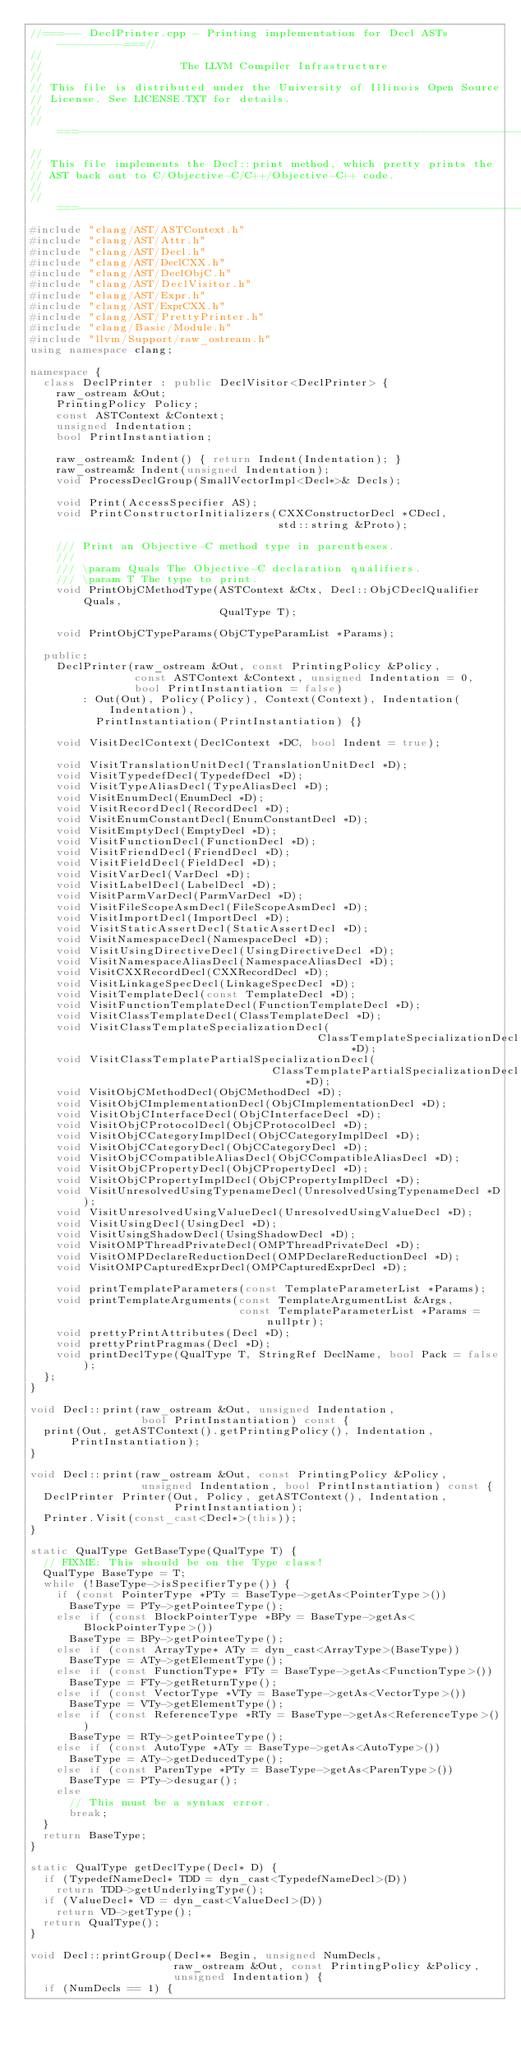Convert code to text. <code><loc_0><loc_0><loc_500><loc_500><_C++_>//===--- DeclPrinter.cpp - Printing implementation for Decl ASTs ----------===//
//
//                     The LLVM Compiler Infrastructure
//
// This file is distributed under the University of Illinois Open Source
// License. See LICENSE.TXT for details.
//
//===----------------------------------------------------------------------===//
//
// This file implements the Decl::print method, which pretty prints the
// AST back out to C/Objective-C/C++/Objective-C++ code.
//
//===----------------------------------------------------------------------===//
#include "clang/AST/ASTContext.h"
#include "clang/AST/Attr.h"
#include "clang/AST/Decl.h"
#include "clang/AST/DeclCXX.h"
#include "clang/AST/DeclObjC.h"
#include "clang/AST/DeclVisitor.h"
#include "clang/AST/Expr.h"
#include "clang/AST/ExprCXX.h"
#include "clang/AST/PrettyPrinter.h"
#include "clang/Basic/Module.h"
#include "llvm/Support/raw_ostream.h"
using namespace clang;

namespace {
  class DeclPrinter : public DeclVisitor<DeclPrinter> {
    raw_ostream &Out;
    PrintingPolicy Policy;
    const ASTContext &Context;
    unsigned Indentation;
    bool PrintInstantiation;

    raw_ostream& Indent() { return Indent(Indentation); }
    raw_ostream& Indent(unsigned Indentation);
    void ProcessDeclGroup(SmallVectorImpl<Decl*>& Decls);

    void Print(AccessSpecifier AS);
    void PrintConstructorInitializers(CXXConstructorDecl *CDecl,
                                      std::string &Proto);

    /// Print an Objective-C method type in parentheses.
    ///
    /// \param Quals The Objective-C declaration qualifiers.
    /// \param T The type to print.
    void PrintObjCMethodType(ASTContext &Ctx, Decl::ObjCDeclQualifier Quals, 
                             QualType T);

    void PrintObjCTypeParams(ObjCTypeParamList *Params);

  public:
    DeclPrinter(raw_ostream &Out, const PrintingPolicy &Policy,
                const ASTContext &Context, unsigned Indentation = 0,
                bool PrintInstantiation = false)
        : Out(Out), Policy(Policy), Context(Context), Indentation(Indentation),
          PrintInstantiation(PrintInstantiation) {}

    void VisitDeclContext(DeclContext *DC, bool Indent = true);

    void VisitTranslationUnitDecl(TranslationUnitDecl *D);
    void VisitTypedefDecl(TypedefDecl *D);
    void VisitTypeAliasDecl(TypeAliasDecl *D);
    void VisitEnumDecl(EnumDecl *D);
    void VisitRecordDecl(RecordDecl *D);
    void VisitEnumConstantDecl(EnumConstantDecl *D);
    void VisitEmptyDecl(EmptyDecl *D);
    void VisitFunctionDecl(FunctionDecl *D);
    void VisitFriendDecl(FriendDecl *D);
    void VisitFieldDecl(FieldDecl *D);
    void VisitVarDecl(VarDecl *D);
    void VisitLabelDecl(LabelDecl *D);
    void VisitParmVarDecl(ParmVarDecl *D);
    void VisitFileScopeAsmDecl(FileScopeAsmDecl *D);
    void VisitImportDecl(ImportDecl *D);
    void VisitStaticAssertDecl(StaticAssertDecl *D);
    void VisitNamespaceDecl(NamespaceDecl *D);
    void VisitUsingDirectiveDecl(UsingDirectiveDecl *D);
    void VisitNamespaceAliasDecl(NamespaceAliasDecl *D);
    void VisitCXXRecordDecl(CXXRecordDecl *D);
    void VisitLinkageSpecDecl(LinkageSpecDecl *D);
    void VisitTemplateDecl(const TemplateDecl *D);
    void VisitFunctionTemplateDecl(FunctionTemplateDecl *D);
    void VisitClassTemplateDecl(ClassTemplateDecl *D);
    void VisitClassTemplateSpecializationDecl(
                                            ClassTemplateSpecializationDecl *D);
    void VisitClassTemplatePartialSpecializationDecl(
                                     ClassTemplatePartialSpecializationDecl *D);
    void VisitObjCMethodDecl(ObjCMethodDecl *D);
    void VisitObjCImplementationDecl(ObjCImplementationDecl *D);
    void VisitObjCInterfaceDecl(ObjCInterfaceDecl *D);
    void VisitObjCProtocolDecl(ObjCProtocolDecl *D);
    void VisitObjCCategoryImplDecl(ObjCCategoryImplDecl *D);
    void VisitObjCCategoryDecl(ObjCCategoryDecl *D);
    void VisitObjCCompatibleAliasDecl(ObjCCompatibleAliasDecl *D);
    void VisitObjCPropertyDecl(ObjCPropertyDecl *D);
    void VisitObjCPropertyImplDecl(ObjCPropertyImplDecl *D);
    void VisitUnresolvedUsingTypenameDecl(UnresolvedUsingTypenameDecl *D);
    void VisitUnresolvedUsingValueDecl(UnresolvedUsingValueDecl *D);
    void VisitUsingDecl(UsingDecl *D);
    void VisitUsingShadowDecl(UsingShadowDecl *D);
    void VisitOMPThreadPrivateDecl(OMPThreadPrivateDecl *D);
    void VisitOMPDeclareReductionDecl(OMPDeclareReductionDecl *D);
    void VisitOMPCapturedExprDecl(OMPCapturedExprDecl *D);

    void printTemplateParameters(const TemplateParameterList *Params);
    void printTemplateArguments(const TemplateArgumentList &Args,
                                const TemplateParameterList *Params = nullptr);
    void prettyPrintAttributes(Decl *D);
    void prettyPrintPragmas(Decl *D);
    void printDeclType(QualType T, StringRef DeclName, bool Pack = false);
  };
}

void Decl::print(raw_ostream &Out, unsigned Indentation,
                 bool PrintInstantiation) const {
  print(Out, getASTContext().getPrintingPolicy(), Indentation, PrintInstantiation);
}

void Decl::print(raw_ostream &Out, const PrintingPolicy &Policy,
                 unsigned Indentation, bool PrintInstantiation) const {
  DeclPrinter Printer(Out, Policy, getASTContext(), Indentation,
                      PrintInstantiation);
  Printer.Visit(const_cast<Decl*>(this));
}

static QualType GetBaseType(QualType T) {
  // FIXME: This should be on the Type class!
  QualType BaseType = T;
  while (!BaseType->isSpecifierType()) {
    if (const PointerType *PTy = BaseType->getAs<PointerType>())
      BaseType = PTy->getPointeeType();
    else if (const BlockPointerType *BPy = BaseType->getAs<BlockPointerType>())
      BaseType = BPy->getPointeeType();
    else if (const ArrayType* ATy = dyn_cast<ArrayType>(BaseType))
      BaseType = ATy->getElementType();
    else if (const FunctionType* FTy = BaseType->getAs<FunctionType>())
      BaseType = FTy->getReturnType();
    else if (const VectorType *VTy = BaseType->getAs<VectorType>())
      BaseType = VTy->getElementType();
    else if (const ReferenceType *RTy = BaseType->getAs<ReferenceType>())
      BaseType = RTy->getPointeeType();
    else if (const AutoType *ATy = BaseType->getAs<AutoType>())
      BaseType = ATy->getDeducedType();
    else if (const ParenType *PTy = BaseType->getAs<ParenType>())
      BaseType = PTy->desugar();
    else
      // This must be a syntax error.
      break;
  }
  return BaseType;
}

static QualType getDeclType(Decl* D) {
  if (TypedefNameDecl* TDD = dyn_cast<TypedefNameDecl>(D))
    return TDD->getUnderlyingType();
  if (ValueDecl* VD = dyn_cast<ValueDecl>(D))
    return VD->getType();
  return QualType();
}

void Decl::printGroup(Decl** Begin, unsigned NumDecls,
                      raw_ostream &Out, const PrintingPolicy &Policy,
                      unsigned Indentation) {
  if (NumDecls == 1) {</code> 